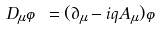Convert formula to latex. <formula><loc_0><loc_0><loc_500><loc_500>D _ { \mu } \varphi = ( \partial _ { \mu } - i q A _ { \mu } ) \varphi</formula> 